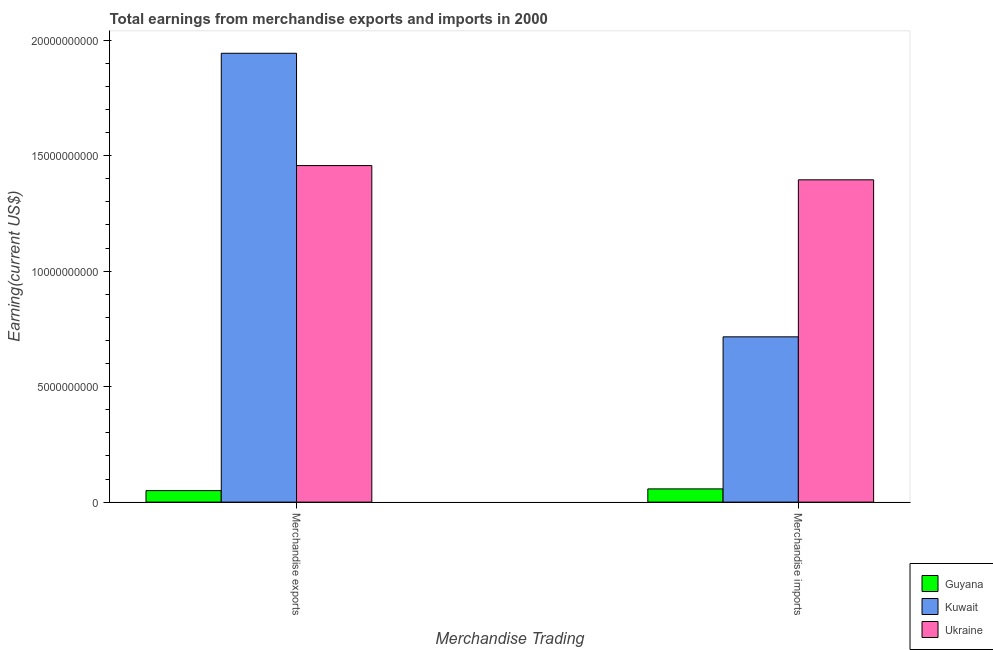How many different coloured bars are there?
Your response must be concise. 3. How many groups of bars are there?
Your answer should be compact. 2. How many bars are there on the 1st tick from the right?
Offer a very short reply. 3. What is the label of the 2nd group of bars from the left?
Offer a terse response. Merchandise imports. What is the earnings from merchandise imports in Kuwait?
Your answer should be compact. 7.16e+09. Across all countries, what is the maximum earnings from merchandise imports?
Your answer should be compact. 1.40e+1. Across all countries, what is the minimum earnings from merchandise exports?
Offer a very short reply. 4.98e+08. In which country was the earnings from merchandise exports maximum?
Provide a short and direct response. Kuwait. In which country was the earnings from merchandise imports minimum?
Your response must be concise. Guyana. What is the total earnings from merchandise exports in the graph?
Offer a very short reply. 3.45e+1. What is the difference between the earnings from merchandise imports in Ukraine and that in Kuwait?
Offer a very short reply. 6.80e+09. What is the difference between the earnings from merchandise exports in Ukraine and the earnings from merchandise imports in Kuwait?
Offer a terse response. 7.42e+09. What is the average earnings from merchandise imports per country?
Provide a succinct answer. 7.23e+09. What is the difference between the earnings from merchandise exports and earnings from merchandise imports in Kuwait?
Keep it short and to the point. 1.23e+1. What is the ratio of the earnings from merchandise exports in Ukraine to that in Kuwait?
Provide a short and direct response. 0.75. In how many countries, is the earnings from merchandise imports greater than the average earnings from merchandise imports taken over all countries?
Keep it short and to the point. 1. What does the 2nd bar from the left in Merchandise exports represents?
Offer a terse response. Kuwait. What does the 1st bar from the right in Merchandise exports represents?
Your response must be concise. Ukraine. How many bars are there?
Offer a very short reply. 6. Are all the bars in the graph horizontal?
Provide a short and direct response. No. Are the values on the major ticks of Y-axis written in scientific E-notation?
Keep it short and to the point. No. Where does the legend appear in the graph?
Provide a succinct answer. Bottom right. How are the legend labels stacked?
Make the answer very short. Vertical. What is the title of the graph?
Ensure brevity in your answer.  Total earnings from merchandise exports and imports in 2000. What is the label or title of the X-axis?
Keep it short and to the point. Merchandise Trading. What is the label or title of the Y-axis?
Your response must be concise. Earning(current US$). What is the Earning(current US$) in Guyana in Merchandise exports?
Your answer should be very brief. 4.98e+08. What is the Earning(current US$) of Kuwait in Merchandise exports?
Your answer should be compact. 1.94e+1. What is the Earning(current US$) in Ukraine in Merchandise exports?
Your answer should be compact. 1.46e+1. What is the Earning(current US$) in Guyana in Merchandise imports?
Make the answer very short. 5.73e+08. What is the Earning(current US$) of Kuwait in Merchandise imports?
Your answer should be compact. 7.16e+09. What is the Earning(current US$) of Ukraine in Merchandise imports?
Give a very brief answer. 1.40e+1. Across all Merchandise Trading, what is the maximum Earning(current US$) in Guyana?
Your response must be concise. 5.73e+08. Across all Merchandise Trading, what is the maximum Earning(current US$) of Kuwait?
Offer a terse response. 1.94e+1. Across all Merchandise Trading, what is the maximum Earning(current US$) in Ukraine?
Ensure brevity in your answer.  1.46e+1. Across all Merchandise Trading, what is the minimum Earning(current US$) in Guyana?
Offer a very short reply. 4.98e+08. Across all Merchandise Trading, what is the minimum Earning(current US$) of Kuwait?
Your response must be concise. 7.16e+09. Across all Merchandise Trading, what is the minimum Earning(current US$) of Ukraine?
Make the answer very short. 1.40e+1. What is the total Earning(current US$) in Guyana in the graph?
Offer a terse response. 1.07e+09. What is the total Earning(current US$) in Kuwait in the graph?
Your answer should be compact. 2.66e+1. What is the total Earning(current US$) of Ukraine in the graph?
Your response must be concise. 2.85e+1. What is the difference between the Earning(current US$) in Guyana in Merchandise exports and that in Merchandise imports?
Your answer should be very brief. -7.50e+07. What is the difference between the Earning(current US$) of Kuwait in Merchandise exports and that in Merchandise imports?
Offer a very short reply. 1.23e+1. What is the difference between the Earning(current US$) of Ukraine in Merchandise exports and that in Merchandise imports?
Make the answer very short. 6.17e+08. What is the difference between the Earning(current US$) in Guyana in Merchandise exports and the Earning(current US$) in Kuwait in Merchandise imports?
Your response must be concise. -6.66e+09. What is the difference between the Earning(current US$) of Guyana in Merchandise exports and the Earning(current US$) of Ukraine in Merchandise imports?
Your response must be concise. -1.35e+1. What is the difference between the Earning(current US$) in Kuwait in Merchandise exports and the Earning(current US$) in Ukraine in Merchandise imports?
Make the answer very short. 5.48e+09. What is the average Earning(current US$) of Guyana per Merchandise Trading?
Your answer should be compact. 5.36e+08. What is the average Earning(current US$) of Kuwait per Merchandise Trading?
Your answer should be compact. 1.33e+1. What is the average Earning(current US$) of Ukraine per Merchandise Trading?
Your response must be concise. 1.43e+1. What is the difference between the Earning(current US$) in Guyana and Earning(current US$) in Kuwait in Merchandise exports?
Offer a very short reply. -1.89e+1. What is the difference between the Earning(current US$) of Guyana and Earning(current US$) of Ukraine in Merchandise exports?
Make the answer very short. -1.41e+1. What is the difference between the Earning(current US$) in Kuwait and Earning(current US$) in Ukraine in Merchandise exports?
Your response must be concise. 4.86e+09. What is the difference between the Earning(current US$) in Guyana and Earning(current US$) in Kuwait in Merchandise imports?
Provide a short and direct response. -6.58e+09. What is the difference between the Earning(current US$) of Guyana and Earning(current US$) of Ukraine in Merchandise imports?
Ensure brevity in your answer.  -1.34e+1. What is the difference between the Earning(current US$) in Kuwait and Earning(current US$) in Ukraine in Merchandise imports?
Your answer should be compact. -6.80e+09. What is the ratio of the Earning(current US$) in Guyana in Merchandise exports to that in Merchandise imports?
Keep it short and to the point. 0.87. What is the ratio of the Earning(current US$) of Kuwait in Merchandise exports to that in Merchandise imports?
Offer a terse response. 2.72. What is the ratio of the Earning(current US$) of Ukraine in Merchandise exports to that in Merchandise imports?
Provide a succinct answer. 1.04. What is the difference between the highest and the second highest Earning(current US$) in Guyana?
Ensure brevity in your answer.  7.50e+07. What is the difference between the highest and the second highest Earning(current US$) of Kuwait?
Your answer should be very brief. 1.23e+1. What is the difference between the highest and the second highest Earning(current US$) in Ukraine?
Offer a very short reply. 6.17e+08. What is the difference between the highest and the lowest Earning(current US$) of Guyana?
Offer a terse response. 7.50e+07. What is the difference between the highest and the lowest Earning(current US$) of Kuwait?
Your answer should be compact. 1.23e+1. What is the difference between the highest and the lowest Earning(current US$) of Ukraine?
Your answer should be compact. 6.17e+08. 